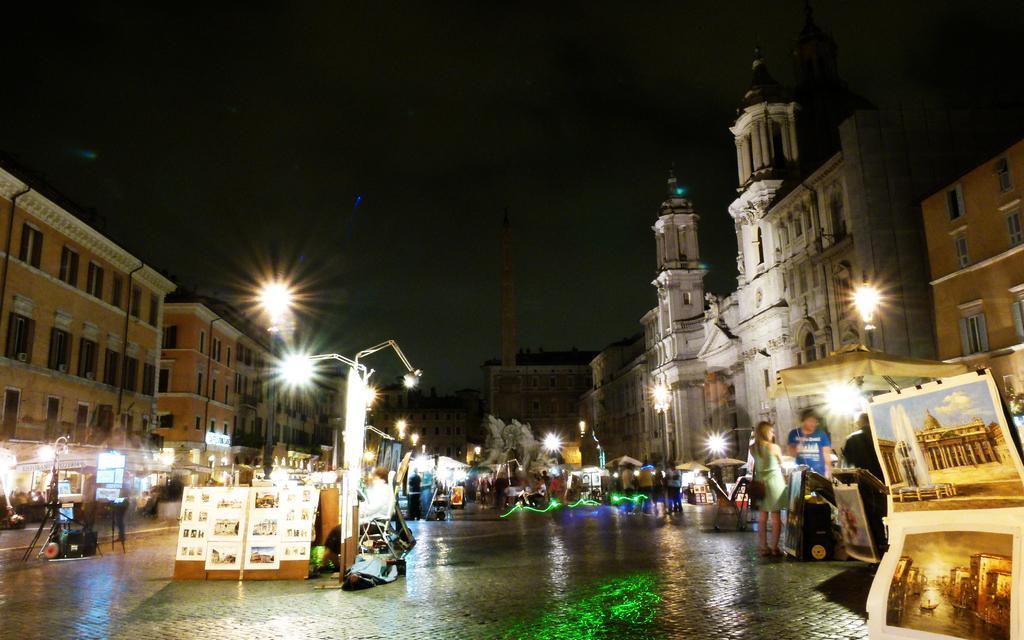How would you summarize this image in a sentence or two? This image is taken during the night time. In this image we can see the buildings, light poles and also the people standing on the path. We can also see the boards with photographs. We can also see some other objects on the path. Image also consists of tents for shelter. Sky is also visible at the top. 